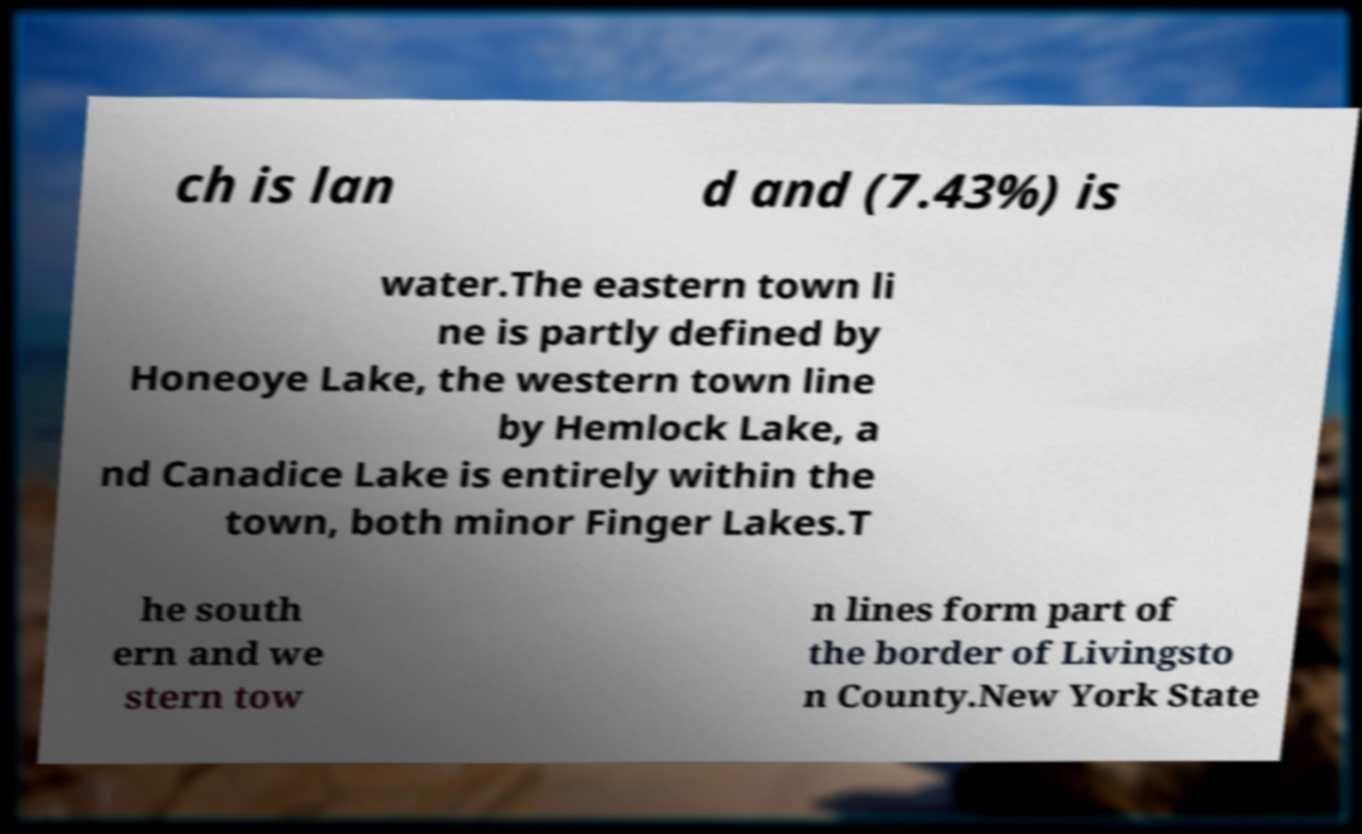Can you accurately transcribe the text from the provided image for me? ch is lan d and (7.43%) is water.The eastern town li ne is partly defined by Honeoye Lake, the western town line by Hemlock Lake, a nd Canadice Lake is entirely within the town, both minor Finger Lakes.T he south ern and we stern tow n lines form part of the border of Livingsto n County.New York State 